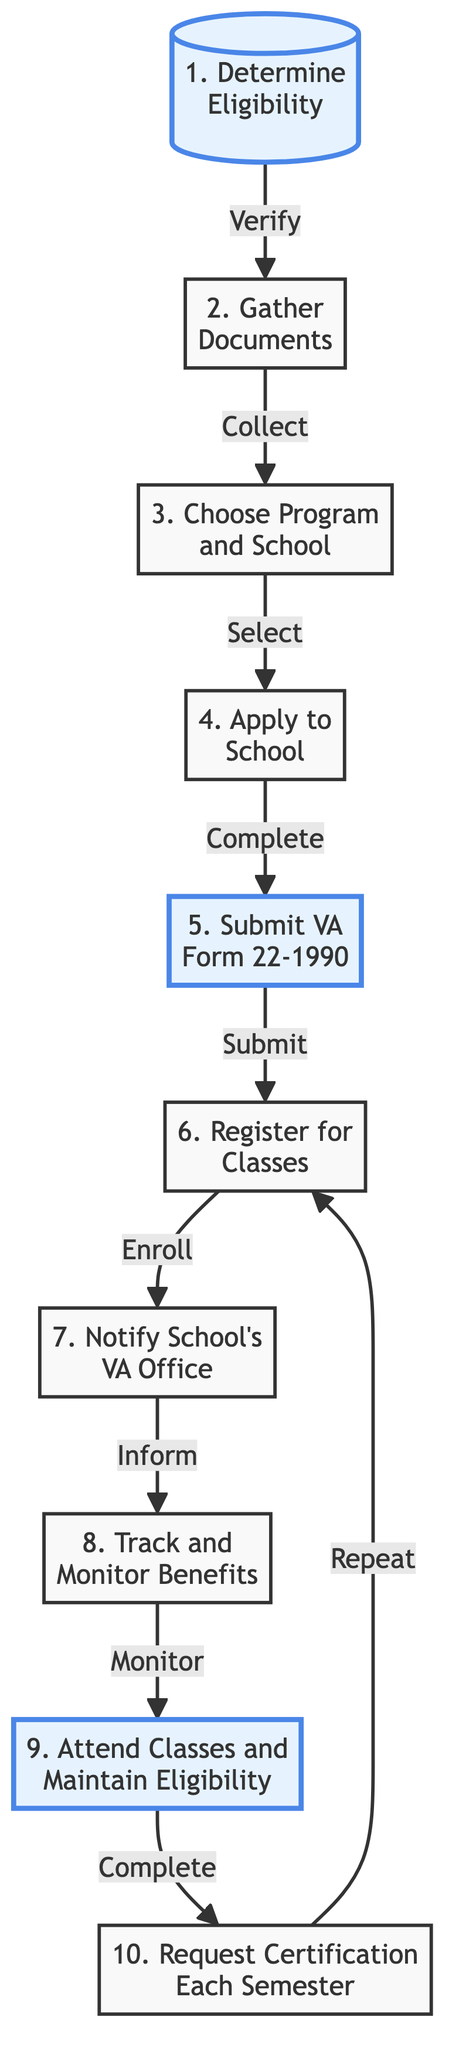What is the first step in the flow chart? The first step is labeled "Determine Eligibility," which is shown at the start of the diagram.
Answer: Determine Eligibility How many steps are there in total in the diagram? Counting each labeled step from 1 to 10, there is a total of 10 steps in the diagram.
Answer: 10 What document is required in Step 2? Step 2 mentions "DD Form 214," which is one of the required documents that need to be gathered.
Answer: DD Form 214 Which step follows the "Notify School's VA Office"? The flow diagram shows that after notifying the school’s VA office, the next step is "Track and Monitor Benefits." This relationship is indicated by the arrow leading from one step to the other.
Answer: Track and Monitor Benefits What is the relationship between Step 4 and Step 5? The relationship is that after completing the admission application in Step 4, the next action is to fill out and submit VA Form 22-1990 in Step 5, as indicated by the directional arrow connecting the two steps.
Answer: Complete → Submit What action is taken in Step 10? In Step 10, the action described is to "Request Certification Each Semester." This relates specifically to the requirement at the end of each term.
Answer: Request Certification Each Semester Which step involves enrollment in courses? Step 6 is focused on enrolling in courses as part of the approved program of study, with the title mentioning "Register for Classes."
Answer: Register for Classes What must be done before registering for classes? Before registering for classes, a student must complete their admission application to the selected school, as indicated in Step 4 of the flow chart.
Answer: Apply to School In which step do you verify eligibility for the GI Bill? Eligibility verification is the first action listed in Step 1, which states "Determine Eligibility." That defines the initial action in the whole process.
Answer: Determine Eligibility What is the final step in the process? The final step in the flow chart is "Request Certification Each Semester," which is labeled as Step 10.
Answer: Request Certification Each Semester 